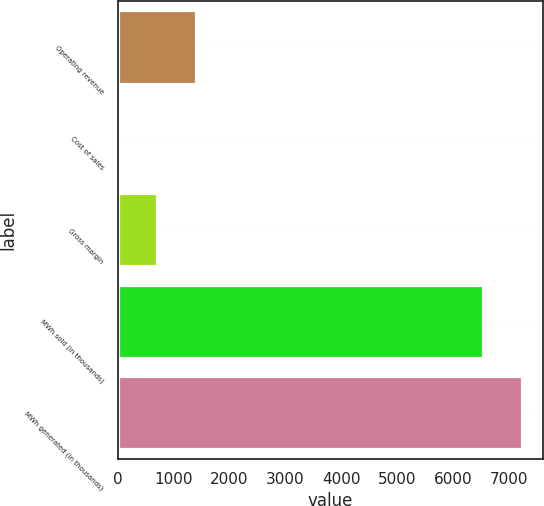Convert chart to OTSL. <chart><loc_0><loc_0><loc_500><loc_500><bar_chart><fcel>Operating revenue<fcel>Cost of sales<fcel>Gross margin<fcel>MWh sold (in thousands)<fcel>MWh generated (in thousands)<nl><fcel>1408<fcel>12<fcel>710<fcel>6534<fcel>7232<nl></chart> 